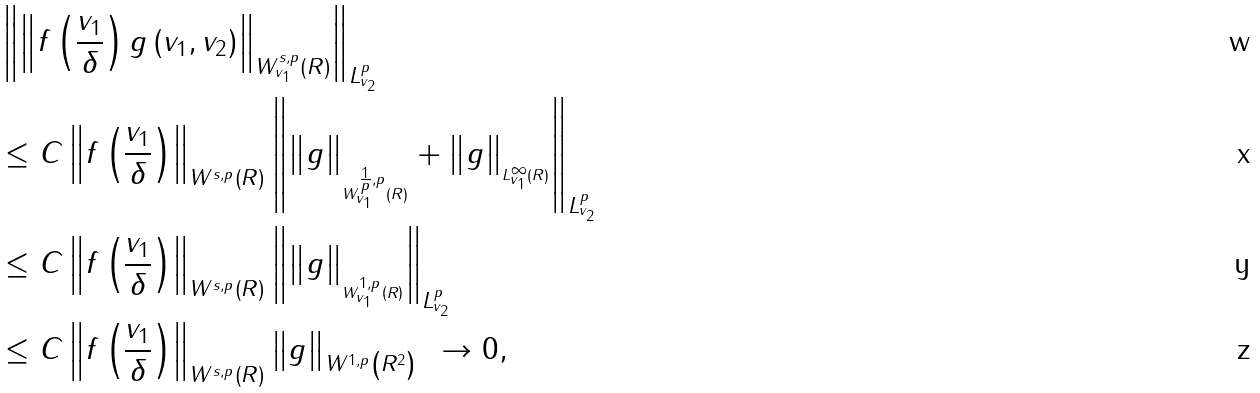Convert formula to latex. <formula><loc_0><loc_0><loc_500><loc_500>& \left \| \left \| f \left ( \frac { v _ { 1 } } { \delta } \right ) g \left ( v _ { 1 } , v _ { 2 } \right ) \right \| _ { W _ { v _ { 1 } } ^ { s , p } \left ( R \right ) } \right \| _ { L _ { v _ { 2 } } ^ { p } } \\ & \leq C \left \| f \left ( \frac { v _ { 1 } } { \delta } \right ) \right \| _ { W ^ { s , p } \left ( R \right ) } \left \| \left \| g \right \| _ { _ { W _ { v _ { 1 } } ^ { \frac { 1 } { p } , p } \left ( R \right ) } } + \left \| g \right \| _ { _ { L _ { v _ { 1 } } ^ { \infty } \left ( R \right ) } } \right \| _ { L _ { v _ { 2 } } ^ { p } } \\ & \leq C \left \| f \left ( \frac { v _ { 1 } } { \delta } \right ) \right \| _ { W ^ { s , p } \left ( R \right ) } \left \| \left \| g \right \| _ { _ { W _ { v _ { 1 } } ^ { 1 , p } \left ( R \right ) } } \right \| _ { L _ { v _ { 2 } } ^ { p } } \\ & \leq C \left \| f \left ( \frac { v _ { 1 } } { \delta } \right ) \right \| _ { W ^ { s , p } \left ( R \right ) } \left \| g \right \| _ { W ^ { 1 , p } \left ( R ^ { 2 } \right ) } \text { } \rightarrow 0 , \</formula> 